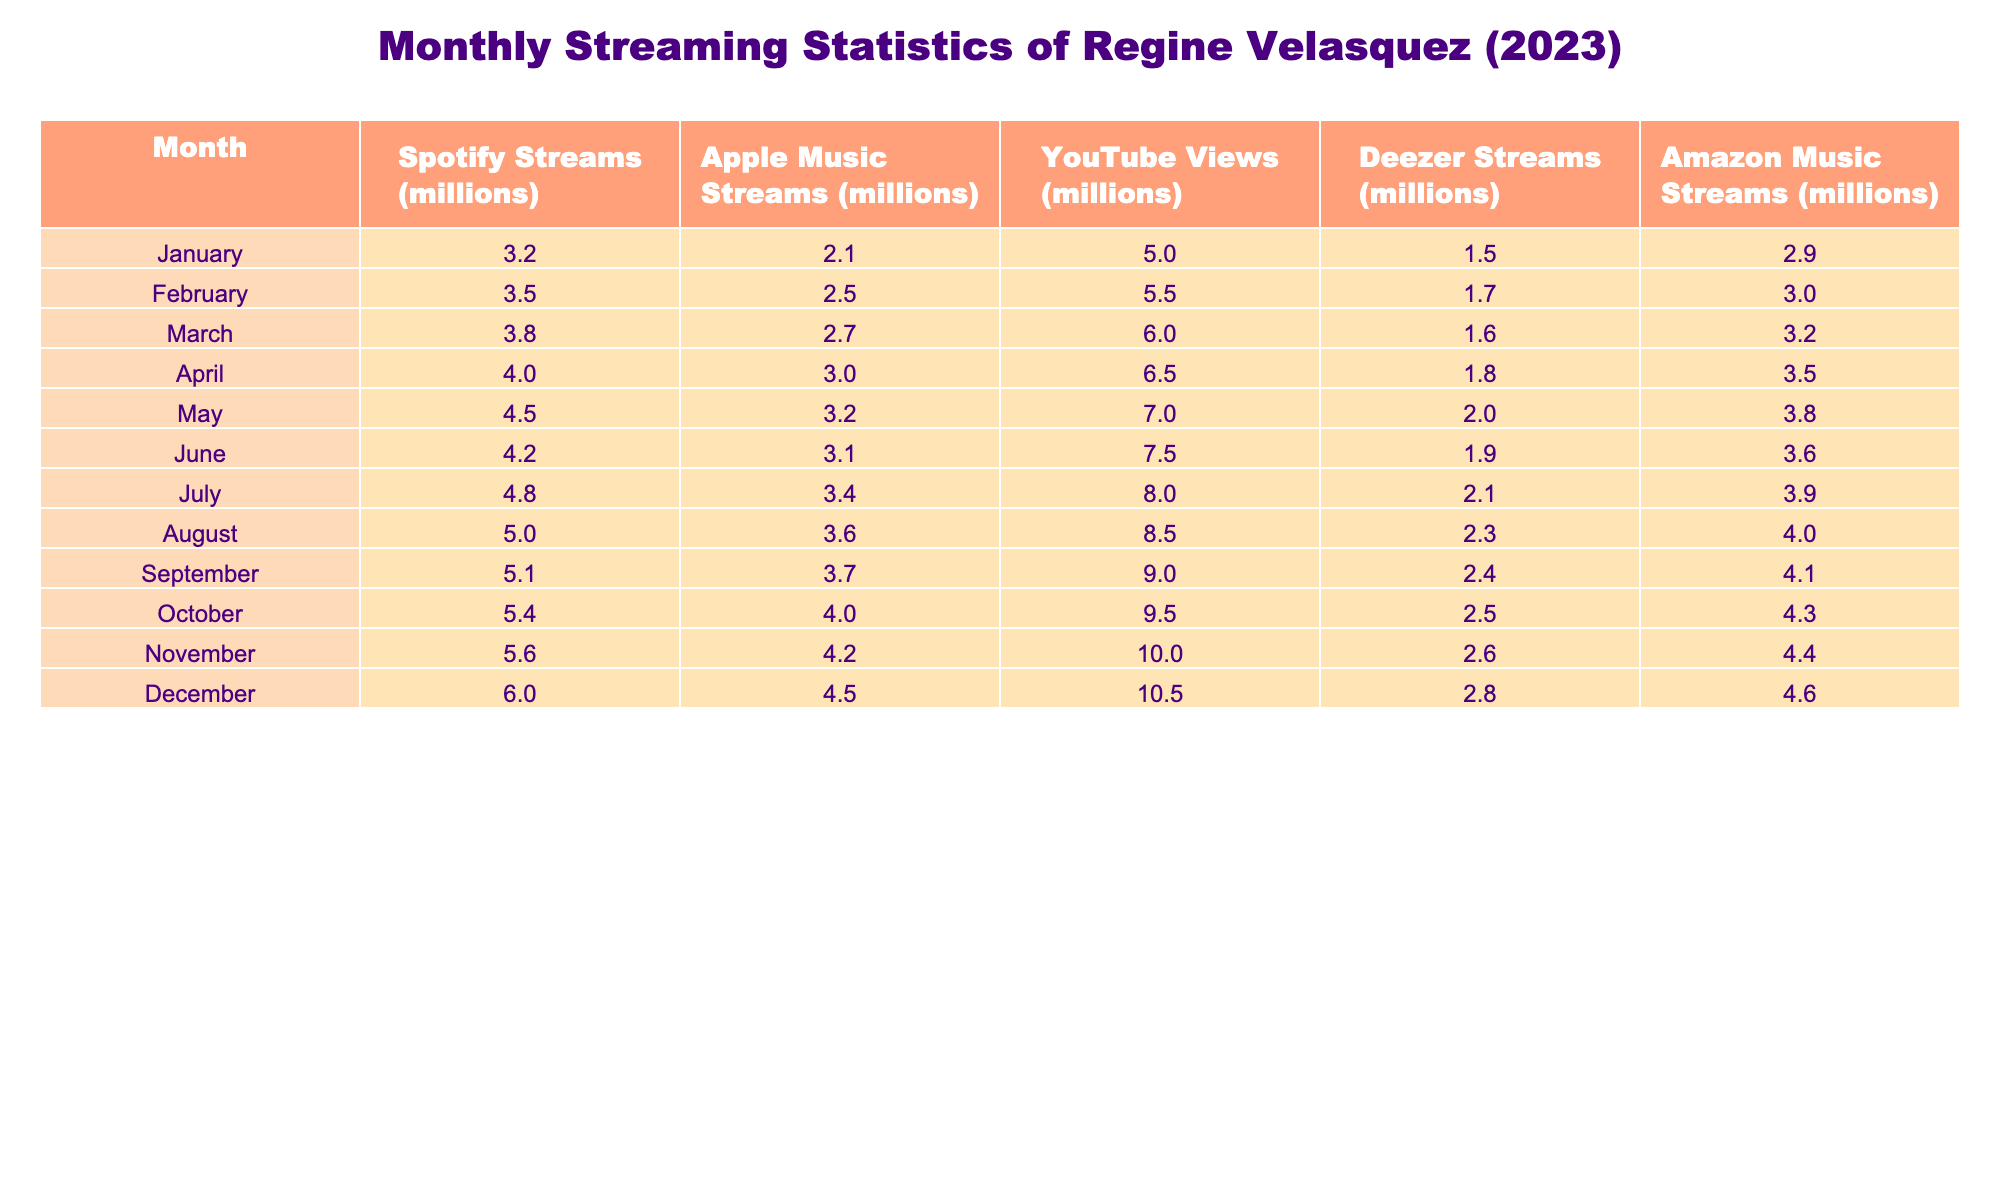What was the total number of YouTube views in December? The table shows that in December, Regine Velasquez had 10.5 million YouTube views. Therefore, the total number of YouTube views in December is simply the value listed for that month.
Answer: 10.5 million Which streaming platform had the highest number of streams in June? By comparing the streams for June across all platforms, Deezer has 1.9 million, Apple Music has 3.1 million, Amazon Music has 3.6 million, Spotify has 4.2 million, and YouTube views are not streams. The highest value is for Spotify at 4.2 million streams.
Answer: Spotify How much did Regine Velasquez's streams on Spotify increase from January to December? In January, the Spotify streams were 3.2 million and in December they were 6.0 million. To find the increase, subtract the January streams from the December streams: 6.0 - 3.2 = 2.8 million.
Answer: 2.8 million What is the average number of Apple Music streams over these twelve months? To calculate the average, sum the monthly Apple Music streams, which are: 2.1 + 2.5 + 2.7 + 3.0 + 3.2 + 3.1 + 3.4 + 3.6 + 3.7 + 4.0 + 4.2 + 4.5 = 40.0 million. Then, divide by the number of months (12): 40.0 / 12 = 3.33 million (approximately).
Answer: 3.33 million Did the monthly YouTube views ever exceed 9 million? From the table, it can be seen that the YouTube views were 9.0 million in September and 9.5 million in October, therefore the views did exceed 9 million in those months.
Answer: Yes Which month saw the lowest amount of total streams across all platforms combined? To find the lowest total, sum the streams for each platform for each month. The total streams for each month are: January (3.2 + 2.1 + 5.0 + 1.5 + 2.9) = 14.7 million, February (3.5 + 2.5 + 5.5 + 1.7 + 3.0) = 16.2 million, and so on. The month with the lowest total is January with 14.7 million.
Answer: January What platform had consistent growth in streams each month? Analyzing the streams for each platform month-by-month, it can be seen that all platforms except for Deezer show consistent growth. Deezer fluctuates with some decreases. Thus, Spotify, Apple Music, and Amazon Music showed consistent growth in streams.
Answer: Spotify, Apple Music, Amazon Music What was the difference in YouTube views between August and November? In August, there were 8.5 million YouTube views and in November, there were 10.0 million. To find the difference, subtract the August views from the November views: 10.0 - 8.5 = 1.5 million.
Answer: 1.5 million How many total streams did Regine Velasquez have across all platforms in May? To find the total streams for May, add the streams from all platforms: 4.5 (Spotify) + 3.2 (Apple Music) + 7.0 (YouTube) + 2.0 (Deezer) + 3.8 (Amazon Music) = 20.5 million.
Answer: 20.5 million In which month did Deezer streams reach 2.5 million or more? Reviewing the table, Deezer streams were above 2.5 million in December (2.8), November (2.6), October (2.5), July (2.1), August (2.3), and June (1.9) months are listed. Therefore, months where Deezer streams were 2.5 million or more are October, November, and December.
Answer: October, November, December Which month had the highest increase in Amazon Music streams compared to the previous month? To determine the highest increase, look at Amazon Music streams for each month and calculate the differences: Between each month, the highest increase was from October to November, rising from 4.3 million to 4.4 million, an increase of 0.1 million.
Answer: November 